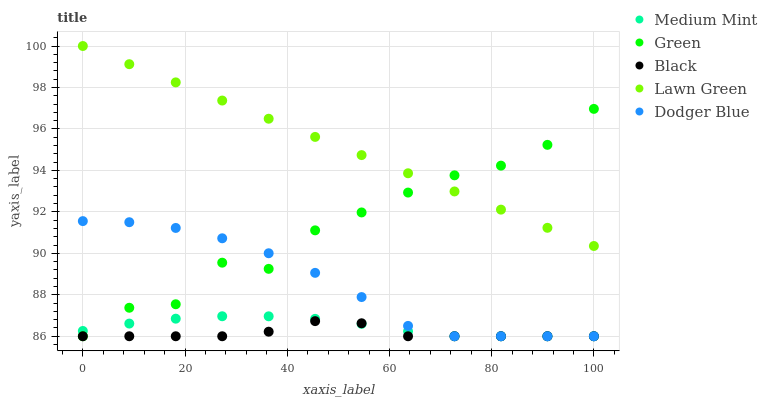Does Black have the minimum area under the curve?
Answer yes or no. Yes. Does Lawn Green have the maximum area under the curve?
Answer yes or no. Yes. Does Green have the minimum area under the curve?
Answer yes or no. No. Does Green have the maximum area under the curve?
Answer yes or no. No. Is Lawn Green the smoothest?
Answer yes or no. Yes. Is Green the roughest?
Answer yes or no. Yes. Is Black the smoothest?
Answer yes or no. No. Is Black the roughest?
Answer yes or no. No. Does Medium Mint have the lowest value?
Answer yes or no. Yes. Does Lawn Green have the lowest value?
Answer yes or no. No. Does Lawn Green have the highest value?
Answer yes or no. Yes. Does Green have the highest value?
Answer yes or no. No. Is Black less than Lawn Green?
Answer yes or no. Yes. Is Lawn Green greater than Medium Mint?
Answer yes or no. Yes. Does Green intersect Lawn Green?
Answer yes or no. Yes. Is Green less than Lawn Green?
Answer yes or no. No. Is Green greater than Lawn Green?
Answer yes or no. No. Does Black intersect Lawn Green?
Answer yes or no. No. 